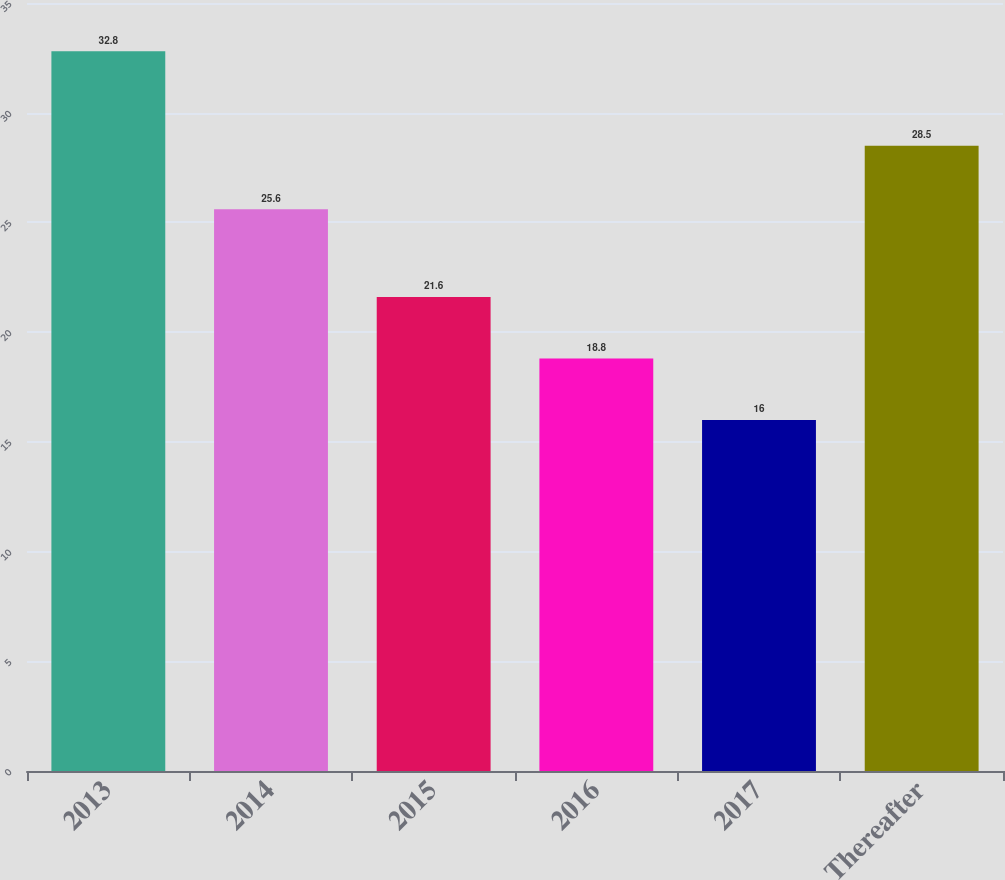<chart> <loc_0><loc_0><loc_500><loc_500><bar_chart><fcel>2013<fcel>2014<fcel>2015<fcel>2016<fcel>2017<fcel>Thereafter<nl><fcel>32.8<fcel>25.6<fcel>21.6<fcel>18.8<fcel>16<fcel>28.5<nl></chart> 